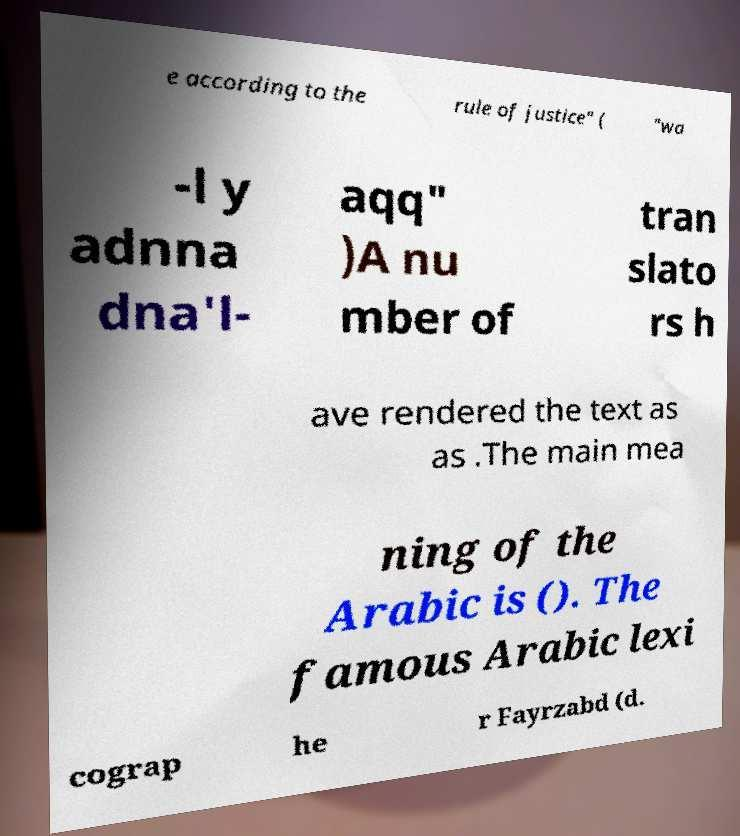What messages or text are displayed in this image? I need them in a readable, typed format. e according to the rule of justice" ( "wa -l y adnna dna'l- aqq" )A nu mber of tran slato rs h ave rendered the text as as .The main mea ning of the Arabic is (). The famous Arabic lexi cograp he r Fayrzabd (d. 